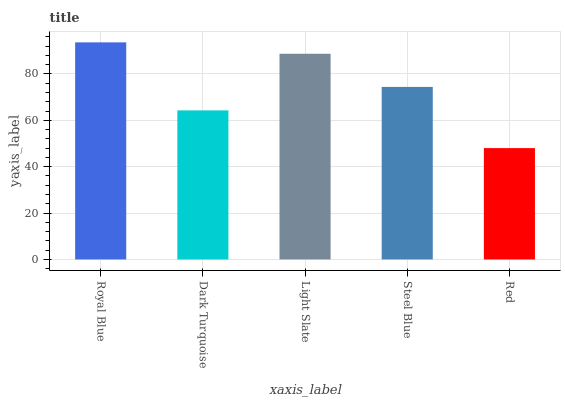Is Dark Turquoise the minimum?
Answer yes or no. No. Is Dark Turquoise the maximum?
Answer yes or no. No. Is Royal Blue greater than Dark Turquoise?
Answer yes or no. Yes. Is Dark Turquoise less than Royal Blue?
Answer yes or no. Yes. Is Dark Turquoise greater than Royal Blue?
Answer yes or no. No. Is Royal Blue less than Dark Turquoise?
Answer yes or no. No. Is Steel Blue the high median?
Answer yes or no. Yes. Is Steel Blue the low median?
Answer yes or no. Yes. Is Red the high median?
Answer yes or no. No. Is Royal Blue the low median?
Answer yes or no. No. 